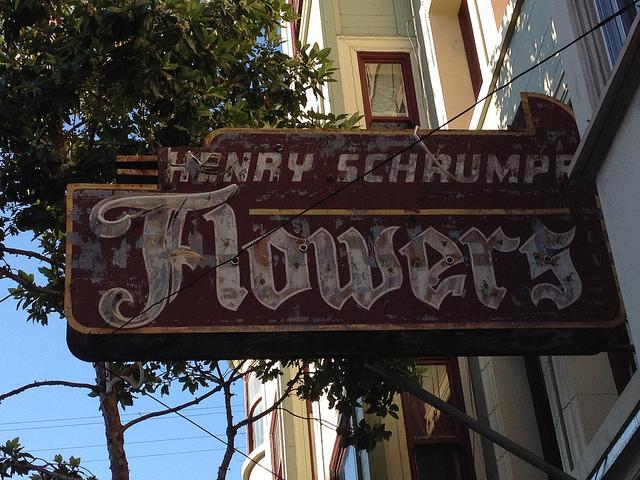What type of store is Henry Schrumps?
Give a very brief answer. Flower. What color are the window frames?
Write a very short answer. Red. Is the sky clear?
Write a very short answer. Yes. 